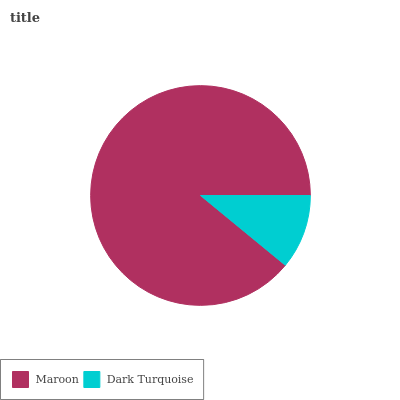Is Dark Turquoise the minimum?
Answer yes or no. Yes. Is Maroon the maximum?
Answer yes or no. Yes. Is Dark Turquoise the maximum?
Answer yes or no. No. Is Maroon greater than Dark Turquoise?
Answer yes or no. Yes. Is Dark Turquoise less than Maroon?
Answer yes or no. Yes. Is Dark Turquoise greater than Maroon?
Answer yes or no. No. Is Maroon less than Dark Turquoise?
Answer yes or no. No. Is Maroon the high median?
Answer yes or no. Yes. Is Dark Turquoise the low median?
Answer yes or no. Yes. Is Dark Turquoise the high median?
Answer yes or no. No. Is Maroon the low median?
Answer yes or no. No. 